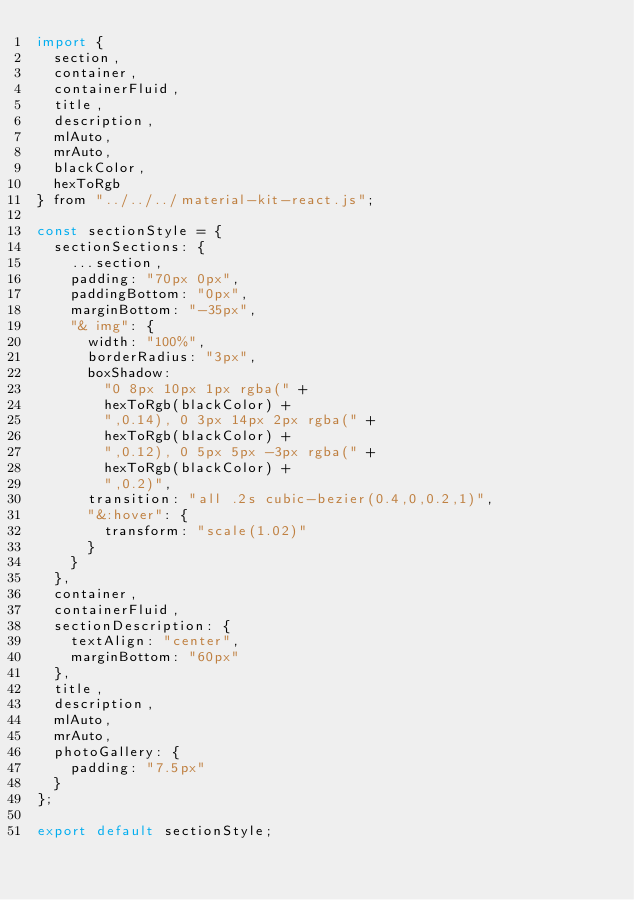Convert code to text. <code><loc_0><loc_0><loc_500><loc_500><_JavaScript_>import {
  section,
  container,
  containerFluid,
  title,
  description,
  mlAuto,
  mrAuto,
  blackColor,
  hexToRgb
} from "../../../material-kit-react.js";

const sectionStyle = {
  sectionSections: {
    ...section,
    padding: "70px 0px",
    paddingBottom: "0px",
    marginBottom: "-35px",
    "& img": {
      width: "100%",
      borderRadius: "3px",
      boxShadow:
        "0 8px 10px 1px rgba(" +
        hexToRgb(blackColor) +
        ",0.14), 0 3px 14px 2px rgba(" +
        hexToRgb(blackColor) +
        ",0.12), 0 5px 5px -3px rgba(" +
        hexToRgb(blackColor) +
        ",0.2)",
      transition: "all .2s cubic-bezier(0.4,0,0.2,1)",
      "&:hover": {
        transform: "scale(1.02)"
      }
    }
  },
  container,
  containerFluid,
  sectionDescription: {
    textAlign: "center",
    marginBottom: "60px"
  },
  title,
  description,
  mlAuto,
  mrAuto,
  photoGallery: {
    padding: "7.5px"
  }
};

export default sectionStyle;
</code> 